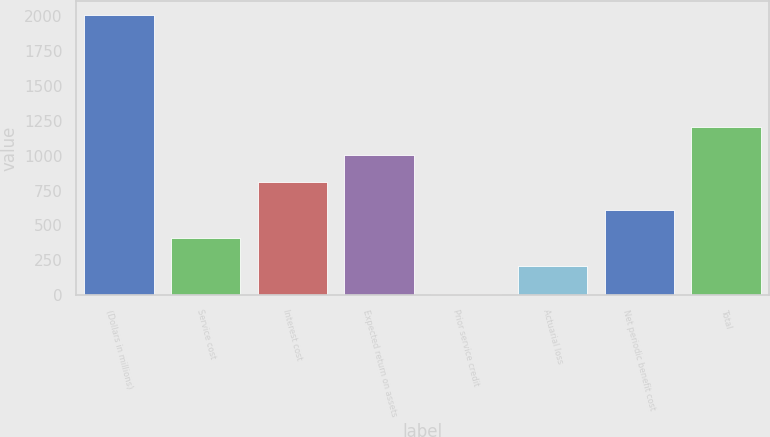Convert chart to OTSL. <chart><loc_0><loc_0><loc_500><loc_500><bar_chart><fcel>(Dollars in millions)<fcel>Service cost<fcel>Interest cost<fcel>Expected return on assets<fcel>Prior service credit<fcel>Actuarial loss<fcel>Net periodic benefit cost<fcel>Total<nl><fcel>2007<fcel>408.6<fcel>808.2<fcel>1008<fcel>9<fcel>208.8<fcel>608.4<fcel>1207.8<nl></chart> 